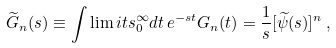<formula> <loc_0><loc_0><loc_500><loc_500>\widetilde { G } _ { n } ( s ) \equiv \int \lim i t s _ { 0 } ^ { \infty } d t \, e ^ { - s t } G _ { n } ( t ) = \frac { 1 } { s } [ \widetilde { \psi } ( s ) ] ^ { n } \, ,</formula> 